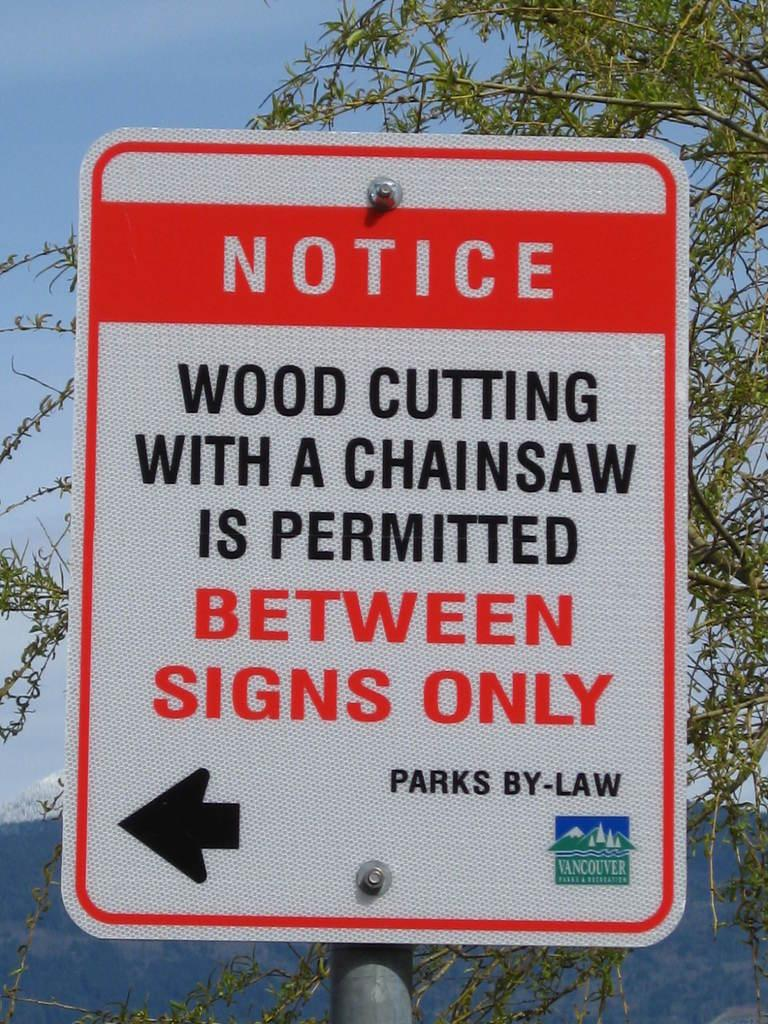<image>
Create a compact narrative representing the image presented. A Notice advises people about the proper places to cut wood with a chainsaw. 